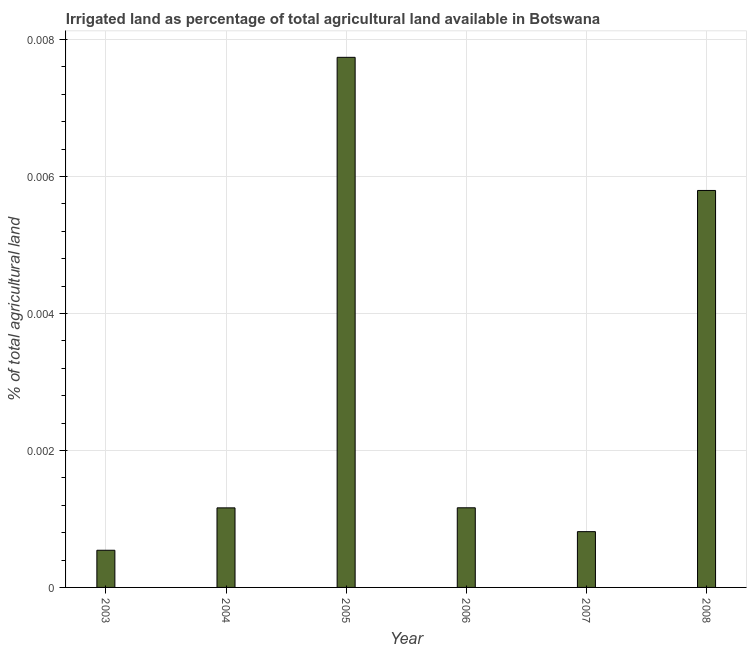Does the graph contain grids?
Provide a short and direct response. Yes. What is the title of the graph?
Provide a short and direct response. Irrigated land as percentage of total agricultural land available in Botswana. What is the label or title of the X-axis?
Your answer should be very brief. Year. What is the label or title of the Y-axis?
Provide a short and direct response. % of total agricultural land. What is the percentage of agricultural irrigated land in 2007?
Give a very brief answer. 0. Across all years, what is the maximum percentage of agricultural irrigated land?
Provide a succinct answer. 0.01. Across all years, what is the minimum percentage of agricultural irrigated land?
Keep it short and to the point. 0. In which year was the percentage of agricultural irrigated land maximum?
Ensure brevity in your answer.  2005. In which year was the percentage of agricultural irrigated land minimum?
Your answer should be very brief. 2003. What is the sum of the percentage of agricultural irrigated land?
Make the answer very short. 0.02. What is the difference between the percentage of agricultural irrigated land in 2005 and 2008?
Your answer should be compact. 0. What is the average percentage of agricultural irrigated land per year?
Ensure brevity in your answer.  0. What is the median percentage of agricultural irrigated land?
Ensure brevity in your answer.  0. In how many years, is the percentage of agricultural irrigated land greater than 0.0016 %?
Your response must be concise. 2. What is the ratio of the percentage of agricultural irrigated land in 2007 to that in 2008?
Keep it short and to the point. 0.14. What is the difference between the highest and the second highest percentage of agricultural irrigated land?
Offer a terse response. 0. Is the sum of the percentage of agricultural irrigated land in 2006 and 2007 greater than the maximum percentage of agricultural irrigated land across all years?
Give a very brief answer. No. What is the difference between two consecutive major ticks on the Y-axis?
Keep it short and to the point. 0. Are the values on the major ticks of Y-axis written in scientific E-notation?
Your response must be concise. No. What is the % of total agricultural land in 2003?
Provide a short and direct response. 0. What is the % of total agricultural land in 2004?
Offer a terse response. 0. What is the % of total agricultural land of 2005?
Offer a very short reply. 0.01. What is the % of total agricultural land in 2006?
Ensure brevity in your answer.  0. What is the % of total agricultural land in 2007?
Your answer should be very brief. 0. What is the % of total agricultural land in 2008?
Your answer should be very brief. 0.01. What is the difference between the % of total agricultural land in 2003 and 2004?
Your answer should be compact. -0. What is the difference between the % of total agricultural land in 2003 and 2005?
Your answer should be compact. -0.01. What is the difference between the % of total agricultural land in 2003 and 2006?
Your response must be concise. -0. What is the difference between the % of total agricultural land in 2003 and 2007?
Provide a short and direct response. -0. What is the difference between the % of total agricultural land in 2003 and 2008?
Your answer should be very brief. -0.01. What is the difference between the % of total agricultural land in 2004 and 2005?
Offer a terse response. -0.01. What is the difference between the % of total agricultural land in 2004 and 2006?
Ensure brevity in your answer.  -0. What is the difference between the % of total agricultural land in 2004 and 2007?
Your answer should be compact. 0. What is the difference between the % of total agricultural land in 2004 and 2008?
Keep it short and to the point. -0. What is the difference between the % of total agricultural land in 2005 and 2006?
Your answer should be compact. 0.01. What is the difference between the % of total agricultural land in 2005 and 2007?
Provide a short and direct response. 0.01. What is the difference between the % of total agricultural land in 2005 and 2008?
Your answer should be very brief. 0. What is the difference between the % of total agricultural land in 2006 and 2007?
Offer a terse response. 0. What is the difference between the % of total agricultural land in 2006 and 2008?
Make the answer very short. -0. What is the difference between the % of total agricultural land in 2007 and 2008?
Your answer should be very brief. -0. What is the ratio of the % of total agricultural land in 2003 to that in 2004?
Give a very brief answer. 0.47. What is the ratio of the % of total agricultural land in 2003 to that in 2005?
Provide a succinct answer. 0.07. What is the ratio of the % of total agricultural land in 2003 to that in 2006?
Offer a terse response. 0.47. What is the ratio of the % of total agricultural land in 2003 to that in 2007?
Keep it short and to the point. 0.67. What is the ratio of the % of total agricultural land in 2003 to that in 2008?
Give a very brief answer. 0.09. What is the ratio of the % of total agricultural land in 2004 to that in 2005?
Provide a short and direct response. 0.15. What is the ratio of the % of total agricultural land in 2004 to that in 2007?
Keep it short and to the point. 1.43. What is the ratio of the % of total agricultural land in 2004 to that in 2008?
Your answer should be compact. 0.2. What is the ratio of the % of total agricultural land in 2005 to that in 2006?
Keep it short and to the point. 6.66. What is the ratio of the % of total agricultural land in 2005 to that in 2007?
Ensure brevity in your answer.  9.5. What is the ratio of the % of total agricultural land in 2005 to that in 2008?
Your answer should be very brief. 1.33. What is the ratio of the % of total agricultural land in 2006 to that in 2007?
Your answer should be compact. 1.43. What is the ratio of the % of total agricultural land in 2006 to that in 2008?
Offer a terse response. 0.2. What is the ratio of the % of total agricultural land in 2007 to that in 2008?
Make the answer very short. 0.14. 